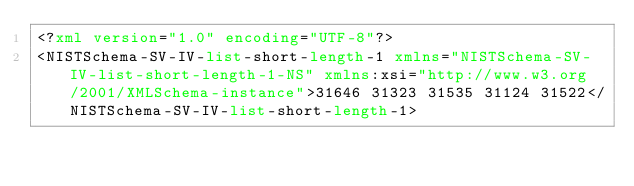<code> <loc_0><loc_0><loc_500><loc_500><_XML_><?xml version="1.0" encoding="UTF-8"?>
<NISTSchema-SV-IV-list-short-length-1 xmlns="NISTSchema-SV-IV-list-short-length-1-NS" xmlns:xsi="http://www.w3.org/2001/XMLSchema-instance">31646 31323 31535 31124 31522</NISTSchema-SV-IV-list-short-length-1>
</code> 